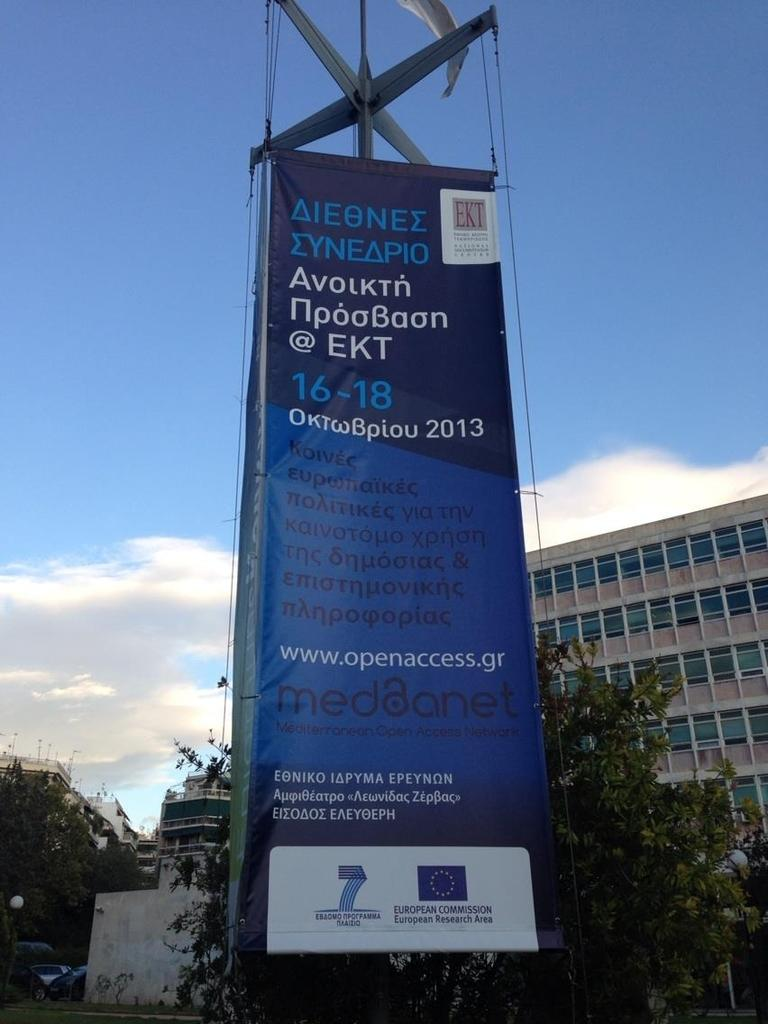<image>
Describe the image concisely. An advertisement for an event that is happening in 2013. 